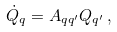Convert formula to latex. <formula><loc_0><loc_0><loc_500><loc_500>\dot { Q } _ { q } = A _ { q q ^ { \prime } } Q _ { q ^ { \prime } } \, ,</formula> 